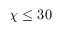Convert formula to latex. <formula><loc_0><loc_0><loc_500><loc_500>\chi \leq 3 0</formula> 